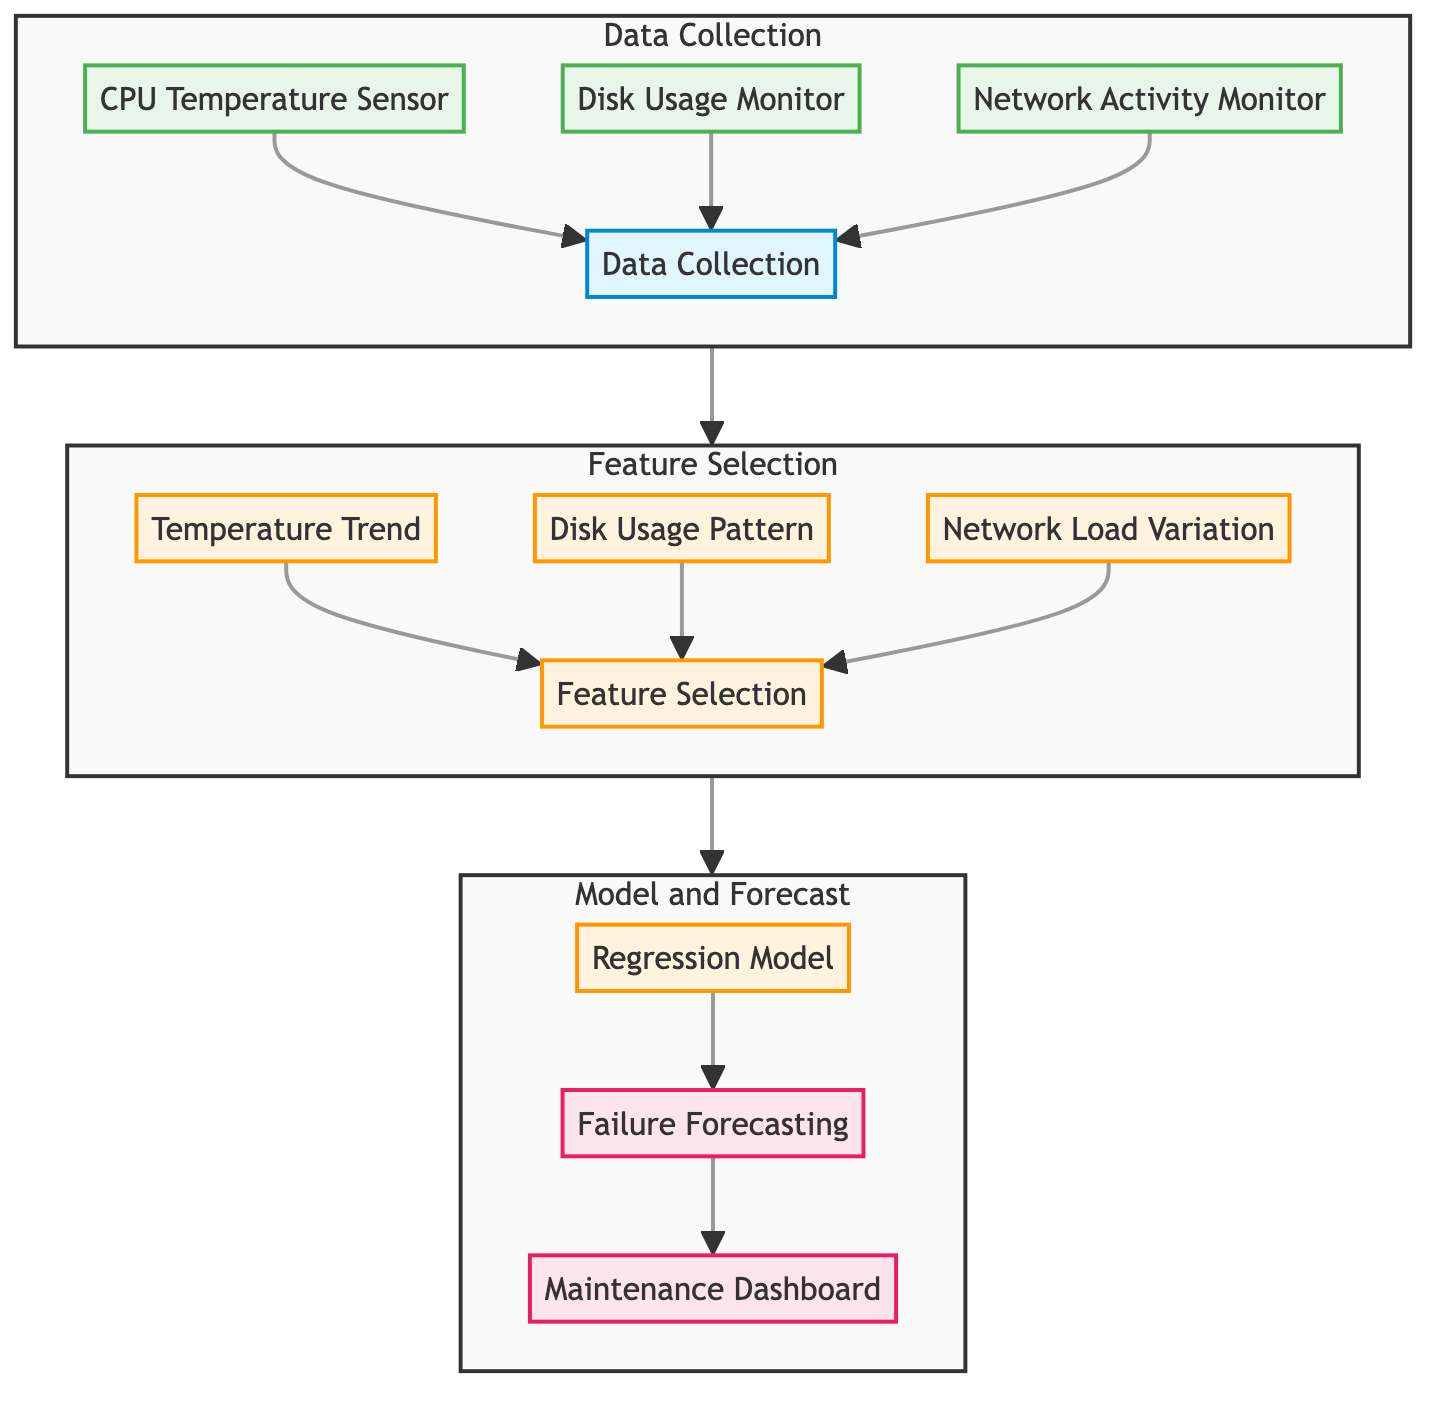What are the sources of data collection in this diagram? The diagram lists three sensors used for data collection: CPU Temperature Sensor, Disk Usage Monitor, and Network Activity Monitor, which feed into the Data Collection node.
Answer: CPU Temperature Sensor, Disk Usage Monitor, Network Activity Monitor How many nodes are in the Feature Selection subgraph? The Feature Selection subgraph contains three nodes: Temperature Trend, Disk Usage Pattern, and Network Load Variation, along with one node for Feature Selection itself, resulting in a total of four nodes.
Answer: Four What is the output of the regression model? The regression model's output leads to Failure Forecasting and the Maintenance Dashboard, making both elements outputs of the model.
Answer: Failure Forecasting, Maintenance Dashboard What is the relationship between data collection and feature selection? Data Collection feeds directly into Feature Selection, indicating that the collected data is used for selecting features for the predictive maintenance models.
Answer: Data Collection feeds into Feature Selection Which processing step directly follows feature selection? The step that directly follows Feature Selection in the diagram is Model and Forecast, indicating that after selecting features, the next action is to build models for prediction.
Answer: Model and Forecast How many total sensors are involved in data collection? There are three sensors shown in the diagram that are used for data collection, which directly contribute data to the overall system.
Answer: Three What are the components included in the Model and Forecast subgraph? The Model and Forecast subgraph includes Regression Model, Failure Forecasting, and Maintenance Dashboard, all of which are elements that deal with predicting hardware failures.
Answer: Regression Model, Failure Forecasting, Maintenance Dashboard Which specific feature is related to network monitoring in the feature selection? The specific feature related to network monitoring in the feature selection process is Network Load Variation, indicating monitoring of network traffic as part of the predictive maintenance system.
Answer: Network Load Variation What is the overall purpose of the diagram? The diagram outlines a predictive maintenance system for server hardware, detailing data collection, feature selection, and regression models to forecast potential hardware failures.
Answer: Predictive maintenance system for server hardware 